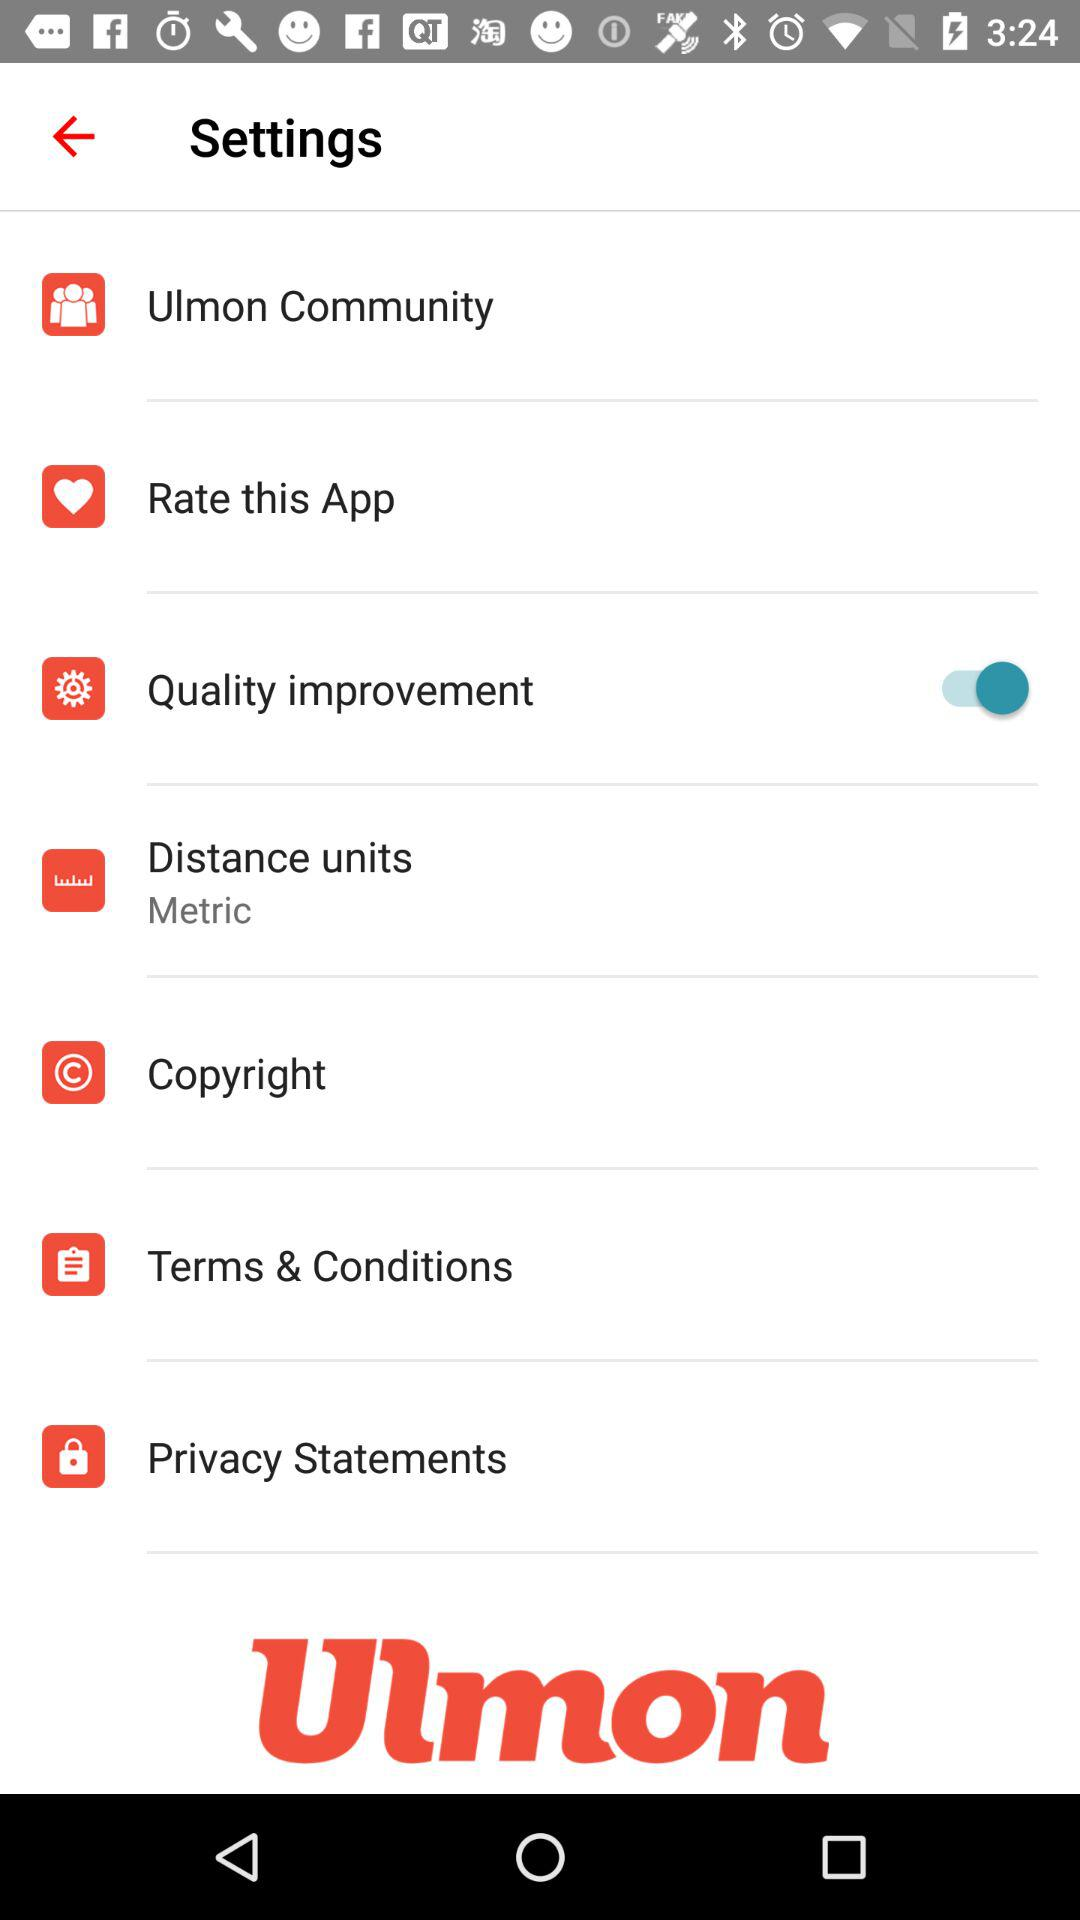What is the application name? The application name is "Ulmon". 